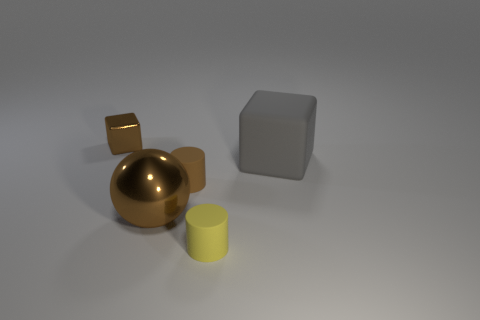What is the material of the tiny brown cube that is left of the large thing in front of the large gray block?
Your answer should be very brief. Metal. Is the ball the same size as the brown matte cylinder?
Your response must be concise. No. What number of objects are cubes that are in front of the small cube or large gray cylinders?
Make the answer very short. 1. There is a small brown object in front of the object behind the big gray rubber thing; what is its shape?
Your answer should be compact. Cylinder. Do the matte block and the brown object behind the rubber cube have the same size?
Ensure brevity in your answer.  No. There is a big thing to the left of the big rubber object; what is its material?
Provide a short and direct response. Metal. How many brown shiny things are both behind the large block and in front of the big gray block?
Keep it short and to the point. 0. What material is the cube that is the same size as the brown shiny ball?
Ensure brevity in your answer.  Rubber. Is the size of the brown metal thing that is right of the metallic cube the same as the cube that is on the right side of the brown cylinder?
Provide a succinct answer. Yes. There is a big gray object; are there any things behind it?
Provide a short and direct response. Yes. 